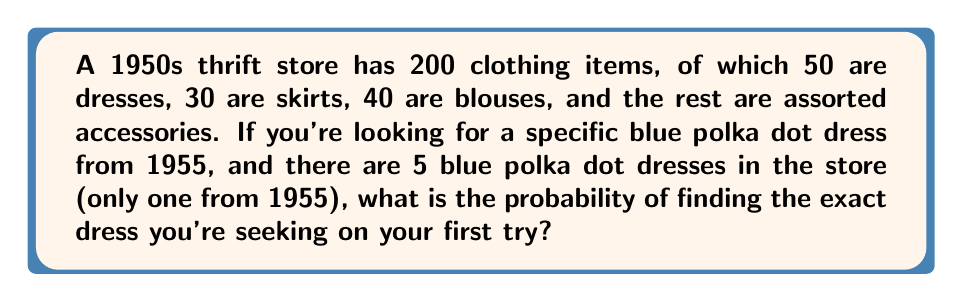Help me with this question. Let's approach this step-by-step:

1. First, we need to identify the total number of items and the number of favorable outcomes:
   - Total items in the store: $n = 200$
   - Number of blue polka dot dresses from 1955: $k = 1$

2. The probability of selecting the specific dress is given by the formula:

   $P(\text{specific dress}) = \frac{\text{number of favorable outcomes}}{\text{total number of possible outcomes}}$

3. Substituting our values:

   $P(\text{specific dress}) = \frac{k}{n} = \frac{1}{200}$

4. To express this as a percentage:

   $P(\text{specific dress}) = \frac{1}{200} \times 100\% = 0.5\%$

Therefore, the probability of finding the exact blue polka dot dress from 1955 on the first try is $\frac{1}{200}$ or $0.5\%$.
Answer: $\frac{1}{200}$ or $0.5\%$ 